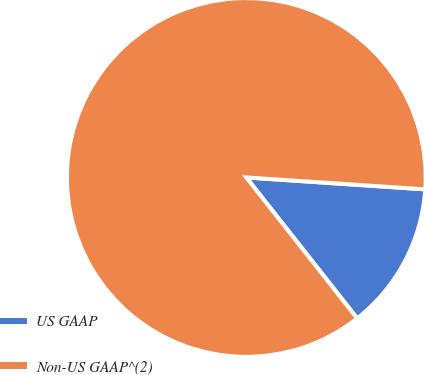Convert chart to OTSL. <chart><loc_0><loc_0><loc_500><loc_500><pie_chart><fcel>US GAAP<fcel>Non-US GAAP^(2)<nl><fcel>13.33%<fcel>86.67%<nl></chart> 